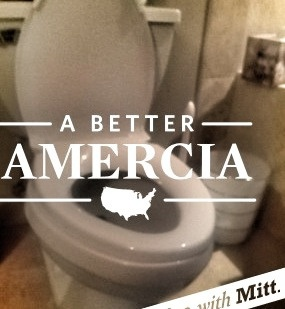Describe the objects in this image and their specific colors. I can see a toilet in maroon, gray, and darkgray tones in this image. 